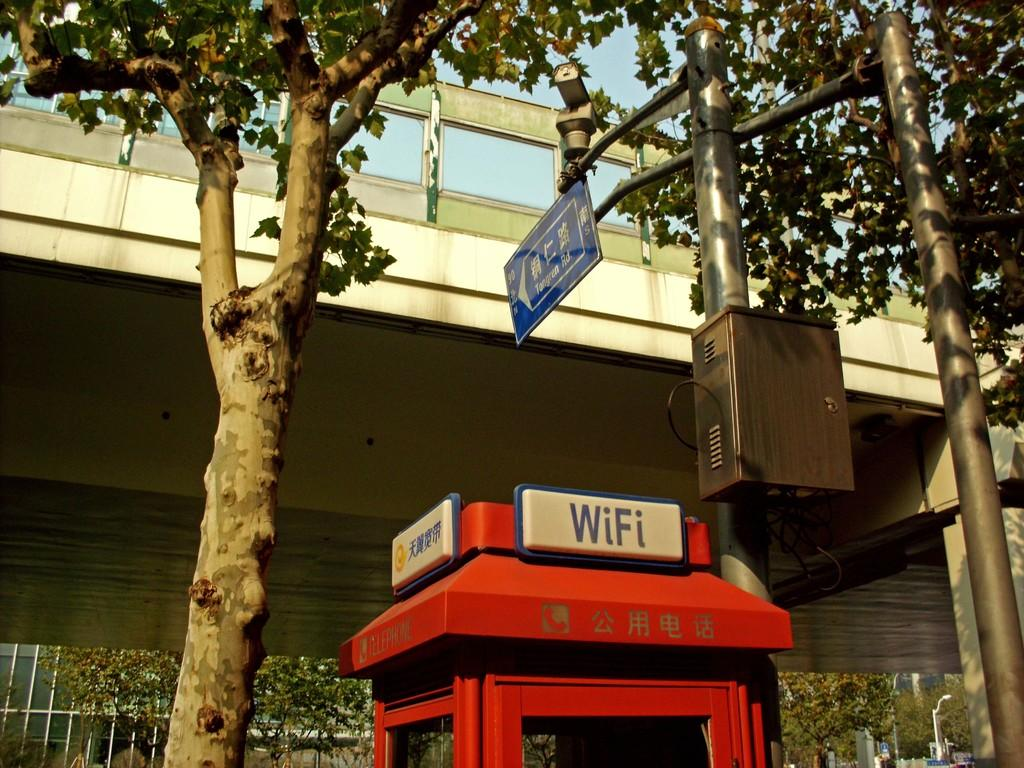<image>
Give a short and clear explanation of the subsequent image. A red box has a sign that reads WiFi. 